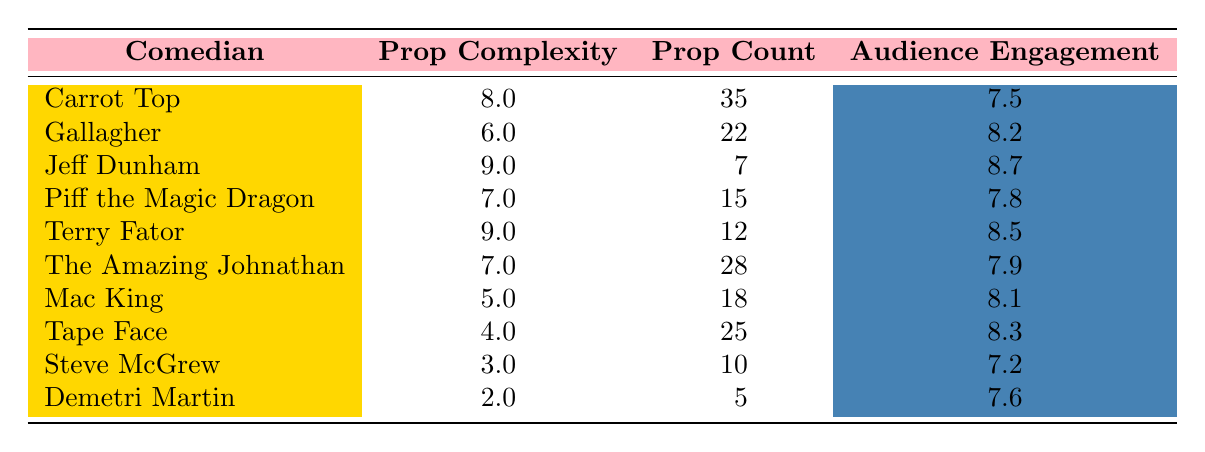What is the prop complexity of Jeff Dunham's special? Jeff Dunham's special "Puppet Master" has a prop complexity of 9, as seen in the table under the prop complexity column corresponding to his row.
Answer: 9 Who has the highest audience engagement score? In the table, Jeff Dunham's audience engagement score is 8.7, which is the highest compared to all other comedians listed.
Answer: Jeff Dunham What is the average prop complexity of the comedians? To find the average, sum the prop complexities: (8 + 6 + 9 + 7 + 9 + 7 + 5 + 4 + 3 + 2) = 60. There are 10 comedians, so the average is 60/10 = 6.0.
Answer: 6.0 Is it true that Mac King has a higher audience engagement score than Carrot Top? Looking at the table, Mac King's audience engagement score is 8.1, while Carrot Top's is 7.5. Therefore, it is true that Mac King has a higher score.
Answer: Yes What is the difference in audience engagement between the highest and lowest scores? The highest audience engagement is 8.7 (Jeff Dunham) and the lowest is 7.2 (Steve McGrew). The difference is 8.7 - 7.2 = 1.5.
Answer: 1.5 Which comedian has the least number of props, and what is that number? From the table, Jeff Dunham has the least number of props listed with a prop count of 7.
Answer: 7 How many comedians have prop complexities greater than 7? The comedians with prop complexities greater than 7 are Carrot Top, Jeff Dunham, and Terry Fator. This totals to 3 comedians.
Answer: 3 What venue hosted the special with the highest prop complexity? The special with the highest prop complexity, which is 9, belongs to both Jeff Dunham and Terry Fator. They performed at Radio City Music Hall and Mirage Las Vegas, respectively.
Answer: Radio City Music Hall and Mirage Las Vegas What is the audience engagement score of the comedian with the second lowest prop complexity? The comedian with the second lowest prop complexity is Tape Face with a complexity of 4, and their audience engagement score is 8.3, as seen in the table.
Answer: 8.3 